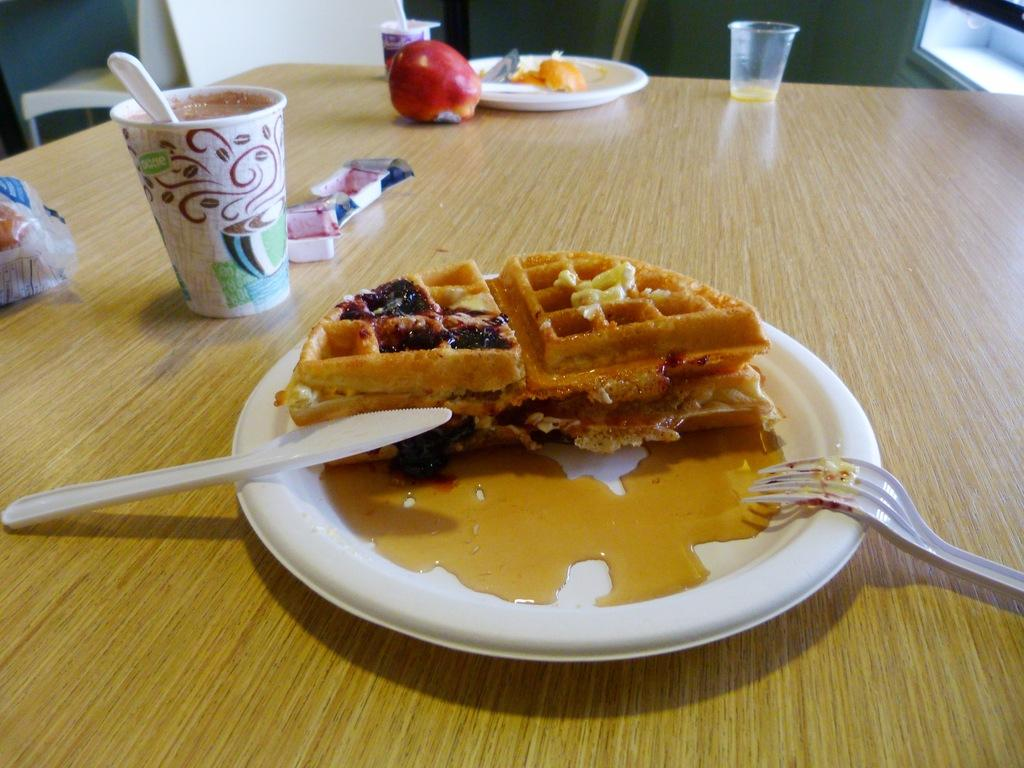What type of furniture is present in the image? There is a table in the image. What items can be seen on the table? There are glasses, plates, an apple, covers, a fork, a knife, and waffles on the table. Is there any seating visible in the image? Yes, there is a chair in the background of the image. What type of veil is draped over the table in the image? There is no veil present in the image; the table has covers on it, but they are not described as veils. 